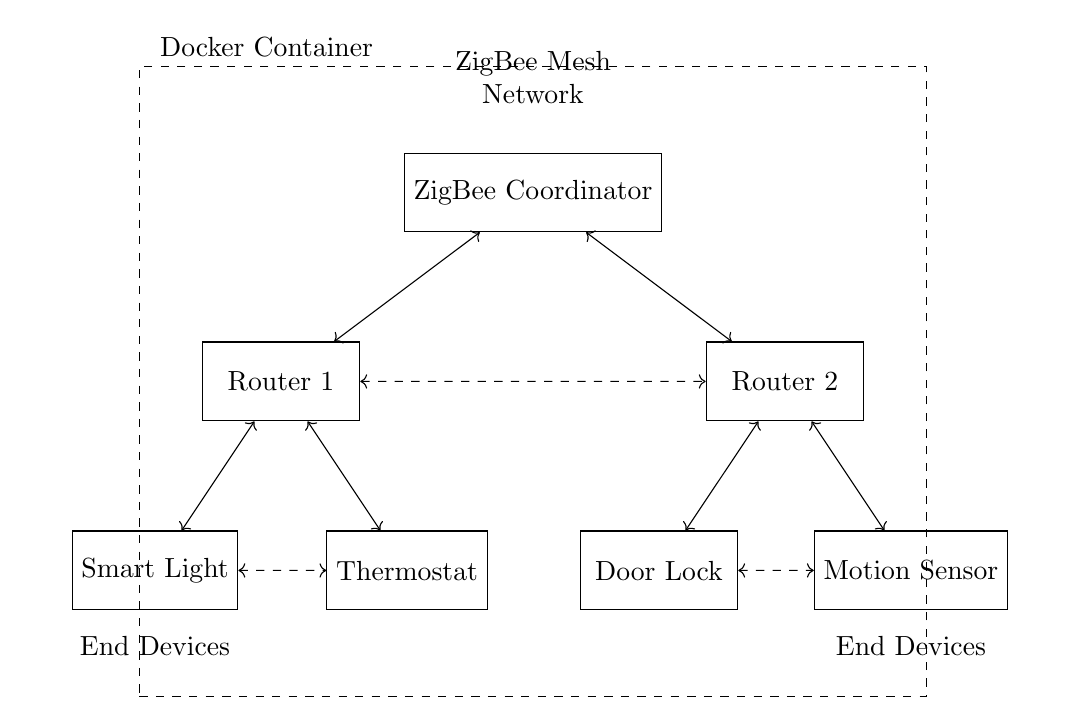What is the main component in the circuit? The main component is the ZigBee Coordinator, which serves as the central point for managing communications in the ZigBee mesh network.
Answer: ZigBee Coordinator How many routers are present in the network? There are two routers in the network, identified as Router 1 and Router 2, which help in relaying messages between devices and the coordinator.
Answer: Two What type of network is represented in this diagram? The diagram represents a ZigBee mesh network, characterized by interconnected devices that communicate with each other for expanded coverage and reliability.
Answer: ZigBee mesh network Which end device is connected to Router 1? The smart light and thermostat are both connected to Router 1, as indicated by the direct connection lines drawn from the router to these devices.
Answer: Smart Light, Thermostat What is the purpose of the dashed lines in the circuit? The dashed lines represent mesh connections, which indicate additional communication paths between Routers and End Devices, allowing for alternative routes for data transfer.
Answer: Mesh connections Which devices are located under Router 2? The door lock and motion sensor are the devices connected to Router 2, shown by the direct lines from Router 2 to these end devices.
Answer: Door Lock, Motion Sensor What does the dashed rectangle represent in the diagram? The dashed rectangle represents the Docker container, indicating that the ZigBee network can be managed and deployed within a Docker environment for better organization and scalability.
Answer: Docker Container 